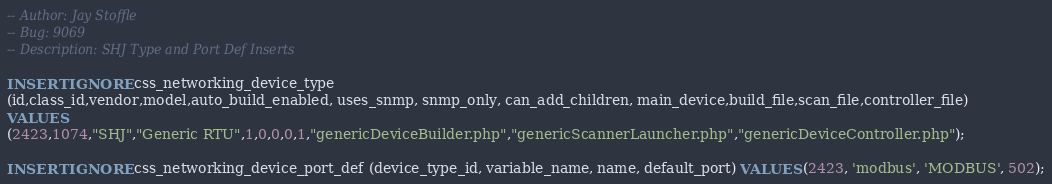Convert code to text. <code><loc_0><loc_0><loc_500><loc_500><_SQL_>-- Author: Jay Stoffle
-- Bug: 9069
-- Description: SHJ Type and Port Def Inserts

INSERT IGNORE css_networking_device_type
(id,class_id,vendor,model,auto_build_enabled, uses_snmp, snmp_only, can_add_children, main_device,build_file,scan_file,controller_file)
VALUES
(2423,1074,"SHJ","Generic RTU",1,0,0,0,1,"genericDeviceBuilder.php","genericScannerLauncher.php","genericDeviceController.php");

INSERT IGNORE css_networking_device_port_def (device_type_id, variable_name, name, default_port) VALUES (2423, 'modbus', 'MODBUS', 502);
</code> 